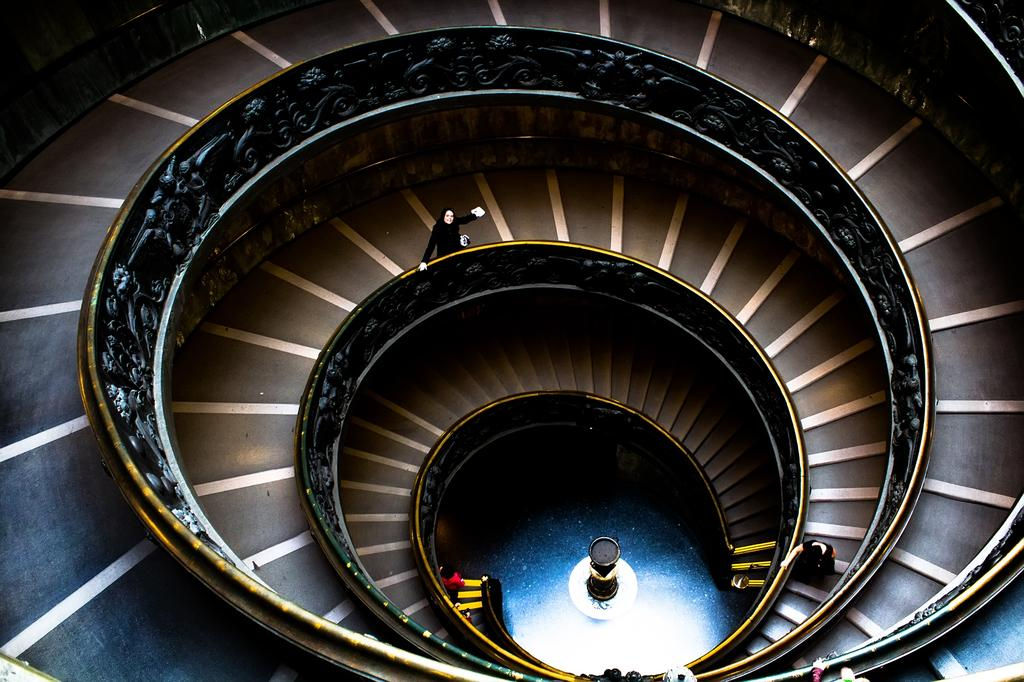What type of staircase is featured in the image? There is a double helix staircase in the image. How many people are present in the image? There are three persons in the image. What type of scarf is draped over the thing in the image? There is no scarf or thing present in the image. 